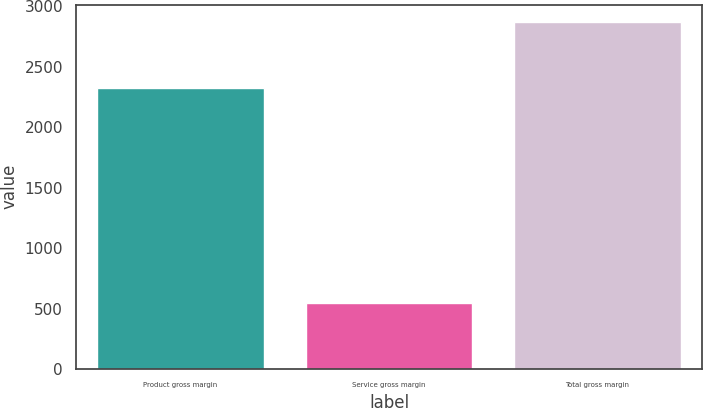<chart> <loc_0><loc_0><loc_500><loc_500><bar_chart><fcel>Product gross margin<fcel>Service gross margin<fcel>Total gross margin<nl><fcel>2323<fcel>545.6<fcel>2868.6<nl></chart> 